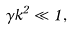<formula> <loc_0><loc_0><loc_500><loc_500>\gamma k ^ { 2 } \ll 1 ,</formula> 